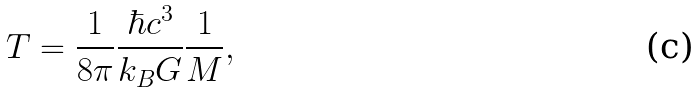<formula> <loc_0><loc_0><loc_500><loc_500>T = \frac { 1 } { 8 \pi } \frac { \hbar { c } ^ { 3 } } { k _ { B } G } \frac { 1 } { M } ,</formula> 